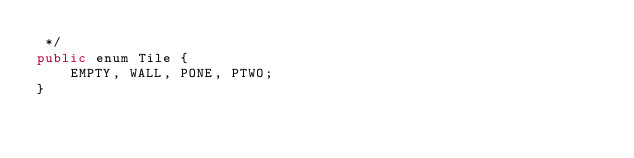Convert code to text. <code><loc_0><loc_0><loc_500><loc_500><_Java_> */
public enum Tile {
	EMPTY, WALL, PONE, PTWO;
}
</code> 